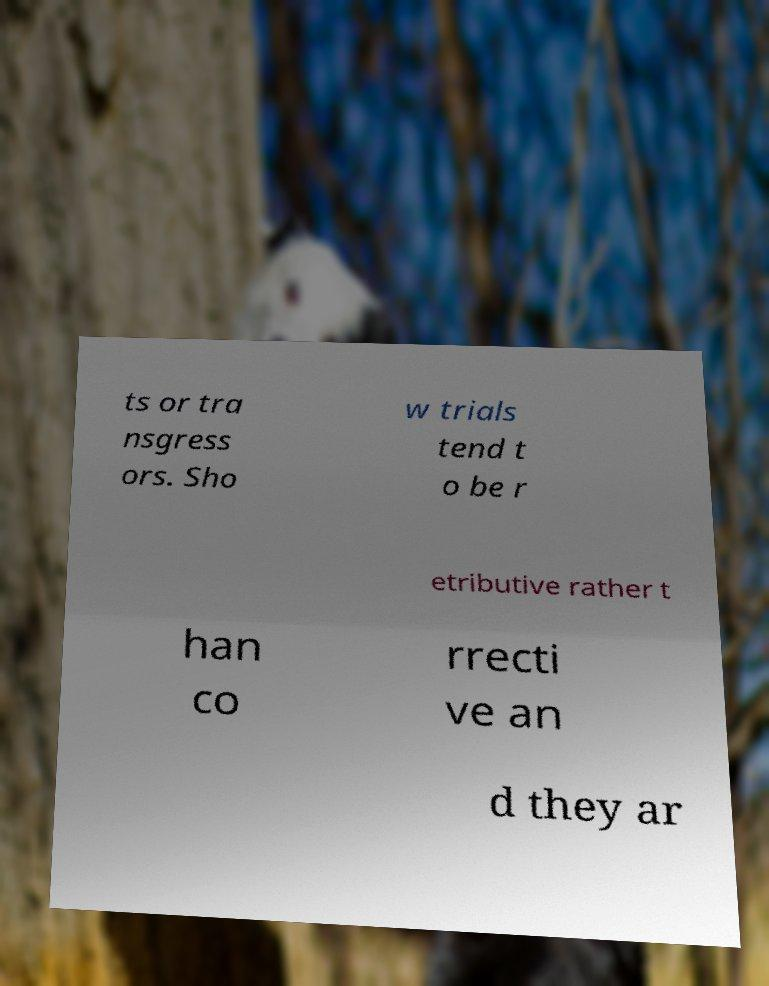I need the written content from this picture converted into text. Can you do that? ts or tra nsgress ors. Sho w trials tend t o be r etributive rather t han co rrecti ve an d they ar 